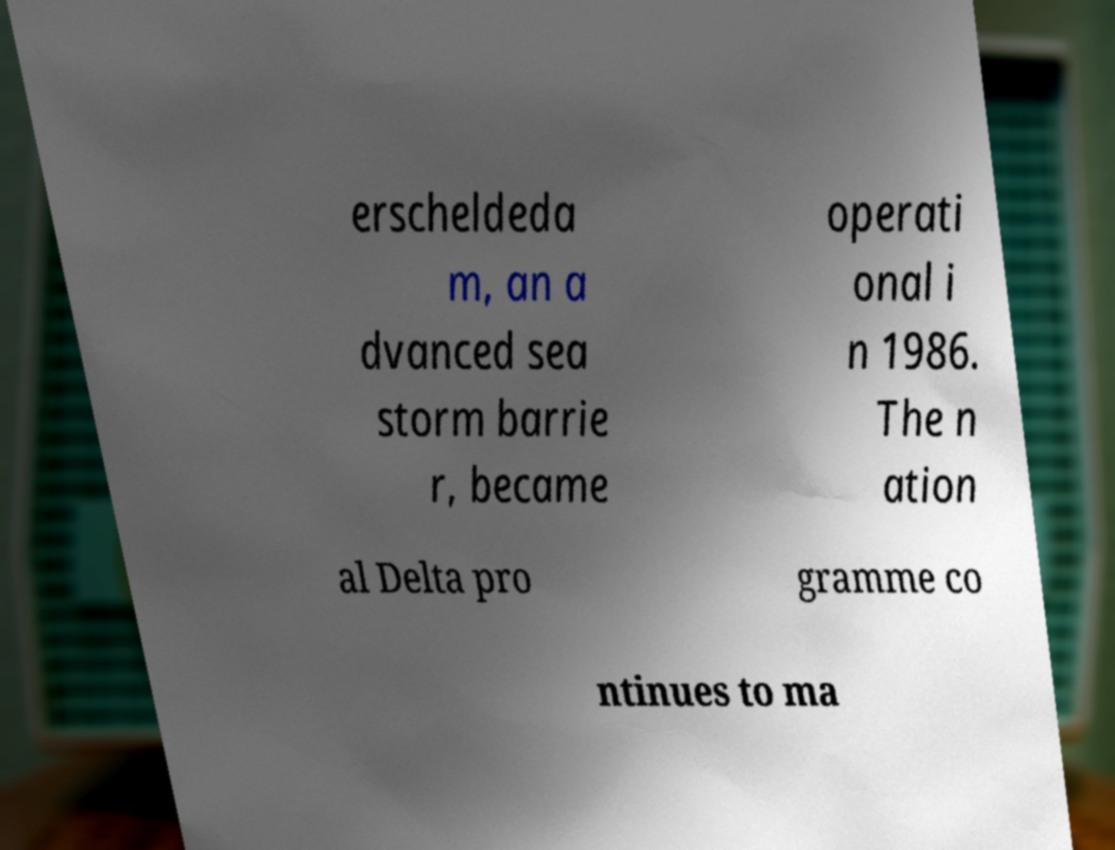Could you assist in decoding the text presented in this image and type it out clearly? erscheldeda m, an a dvanced sea storm barrie r, became operati onal i n 1986. The n ation al Delta pro gramme co ntinues to ma 